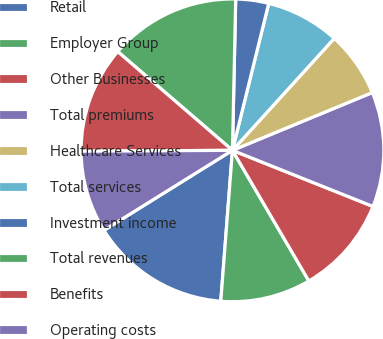Convert chart to OTSL. <chart><loc_0><loc_0><loc_500><loc_500><pie_chart><fcel>Retail<fcel>Employer Group<fcel>Other Businesses<fcel>Total premiums<fcel>Healthcare Services<fcel>Total services<fcel>Investment income<fcel>Total revenues<fcel>Benefits<fcel>Operating costs<nl><fcel>14.91%<fcel>9.65%<fcel>10.53%<fcel>12.28%<fcel>7.02%<fcel>7.89%<fcel>3.51%<fcel>14.03%<fcel>11.4%<fcel>8.77%<nl></chart> 